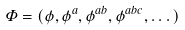<formula> <loc_0><loc_0><loc_500><loc_500>\Phi = ( \phi , \phi ^ { a } , \phi ^ { a b } , \phi ^ { a b c } , \dots )</formula> 